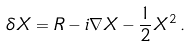<formula> <loc_0><loc_0><loc_500><loc_500>\delta X = R - i \nabla X - \frac { 1 } { 2 } X ^ { 2 } \, .</formula> 